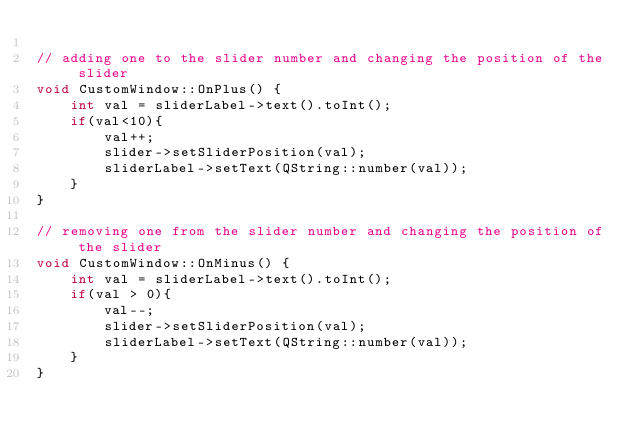<code> <loc_0><loc_0><loc_500><loc_500><_C++_>
// adding one to the slider number and changing the position of the slider
void CustomWindow::OnPlus() {
    int val = sliderLabel->text().toInt();
    if(val<10){
        val++;
        slider->setSliderPosition(val);
        sliderLabel->setText(QString::number(val));
    }
}

// removing one from the slider number and changing the position of the slider
void CustomWindow::OnMinus() {
    int val = sliderLabel->text().toInt();
    if(val > 0){
        val--;
        slider->setSliderPosition(val);
        sliderLabel->setText(QString::number(val));
    }
}


</code> 